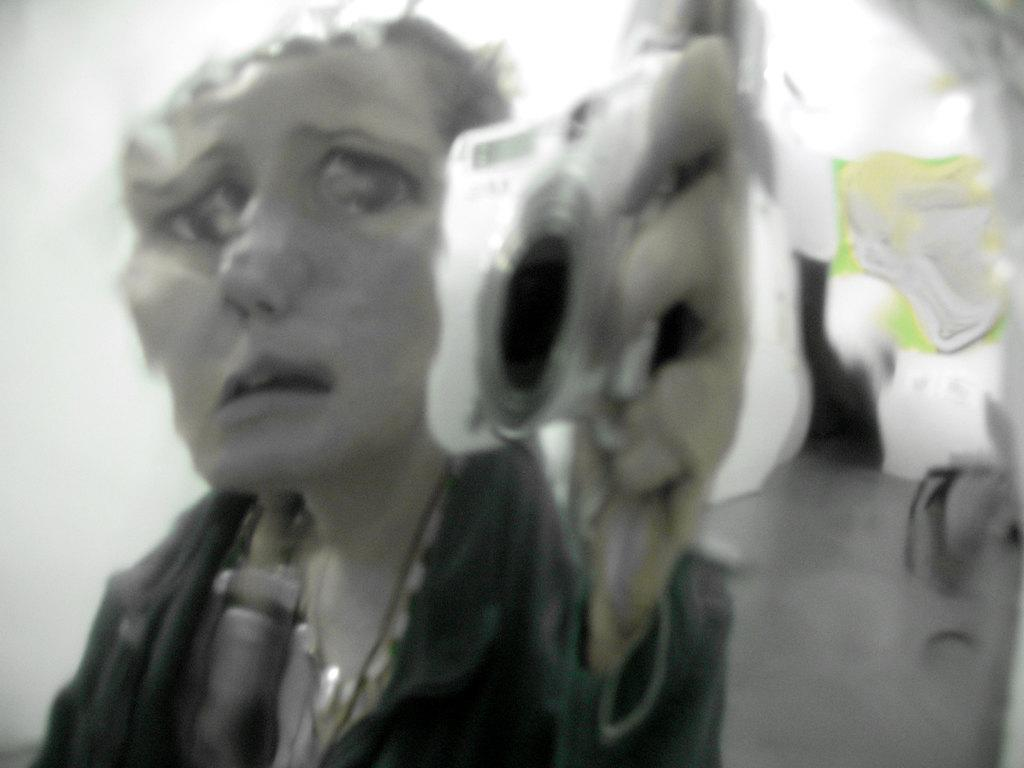Who is present in the image? There is a woman in the image. What is the woman wearing? The woman is wearing clothes. What is the woman holding in her hand? The woman is holding a camera in her hand. What is the surface beneath the woman in the image? The image shows a floor. How many twigs are visible in the woman's hair in the image? There are no twigs visible in the woman's hair in the image. What type of flock is flying in the background of the image? There is no flock visible in the background of the image. 